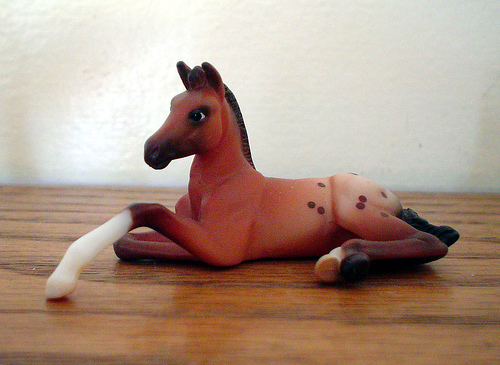<image>
Is there a horse on the wood? Yes. Looking at the image, I can see the horse is positioned on top of the wood, with the wood providing support. 